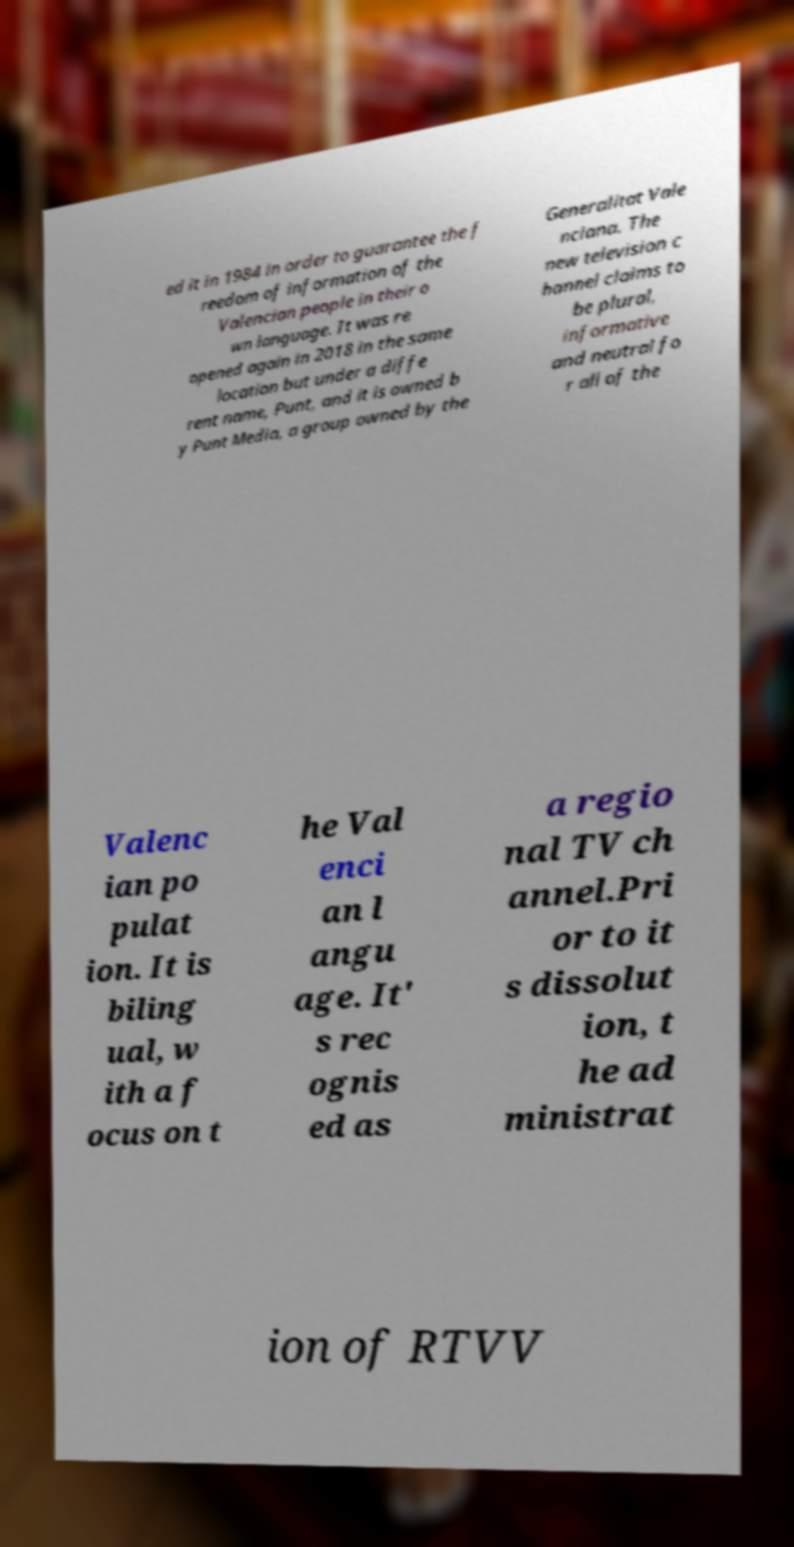There's text embedded in this image that I need extracted. Can you transcribe it verbatim? ed it in 1984 in order to guarantee the f reedom of information of the Valencian people in their o wn language. It was re opened again in 2018 in the same location but under a diffe rent name, Punt, and it is owned b y Punt Media, a group owned by the Generalitat Vale nciana. The new television c hannel claims to be plural, informative and neutral fo r all of the Valenc ian po pulat ion. It is biling ual, w ith a f ocus on t he Val enci an l angu age. It' s rec ognis ed as a regio nal TV ch annel.Pri or to it s dissolut ion, t he ad ministrat ion of RTVV 